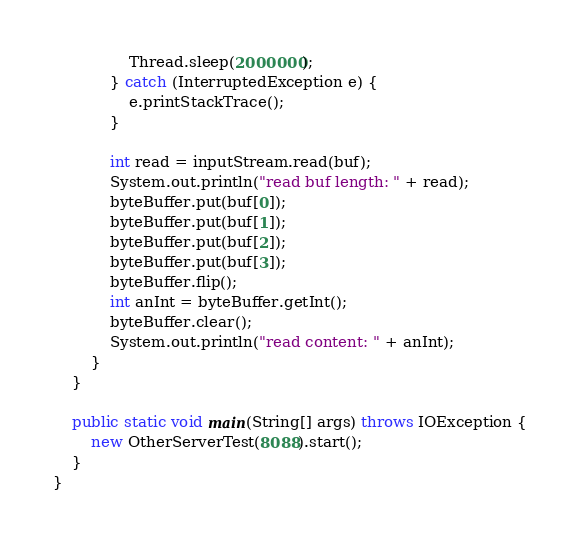<code> <loc_0><loc_0><loc_500><loc_500><_Java_>                Thread.sleep(2000000);
            } catch (InterruptedException e) {
                e.printStackTrace();
            }

            int read = inputStream.read(buf);
            System.out.println("read buf length: " + read);
            byteBuffer.put(buf[0]);
            byteBuffer.put(buf[1]);
            byteBuffer.put(buf[2]);
            byteBuffer.put(buf[3]);
            byteBuffer.flip();
            int anInt = byteBuffer.getInt();
            byteBuffer.clear();
            System.out.println("read content: " + anInt);
        }
    }

    public static void main(String[] args) throws IOException {
        new OtherServerTest(8088).start();
    }
}
</code> 